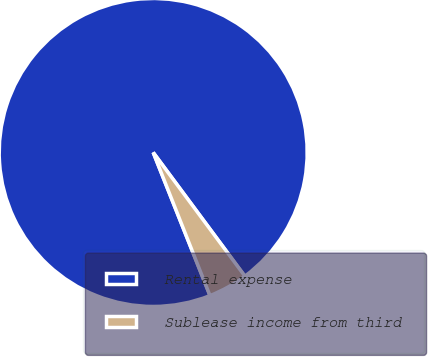Convert chart to OTSL. <chart><loc_0><loc_0><loc_500><loc_500><pie_chart><fcel>Rental expense<fcel>Sublease income from third<nl><fcel>95.86%<fcel>4.14%<nl></chart> 